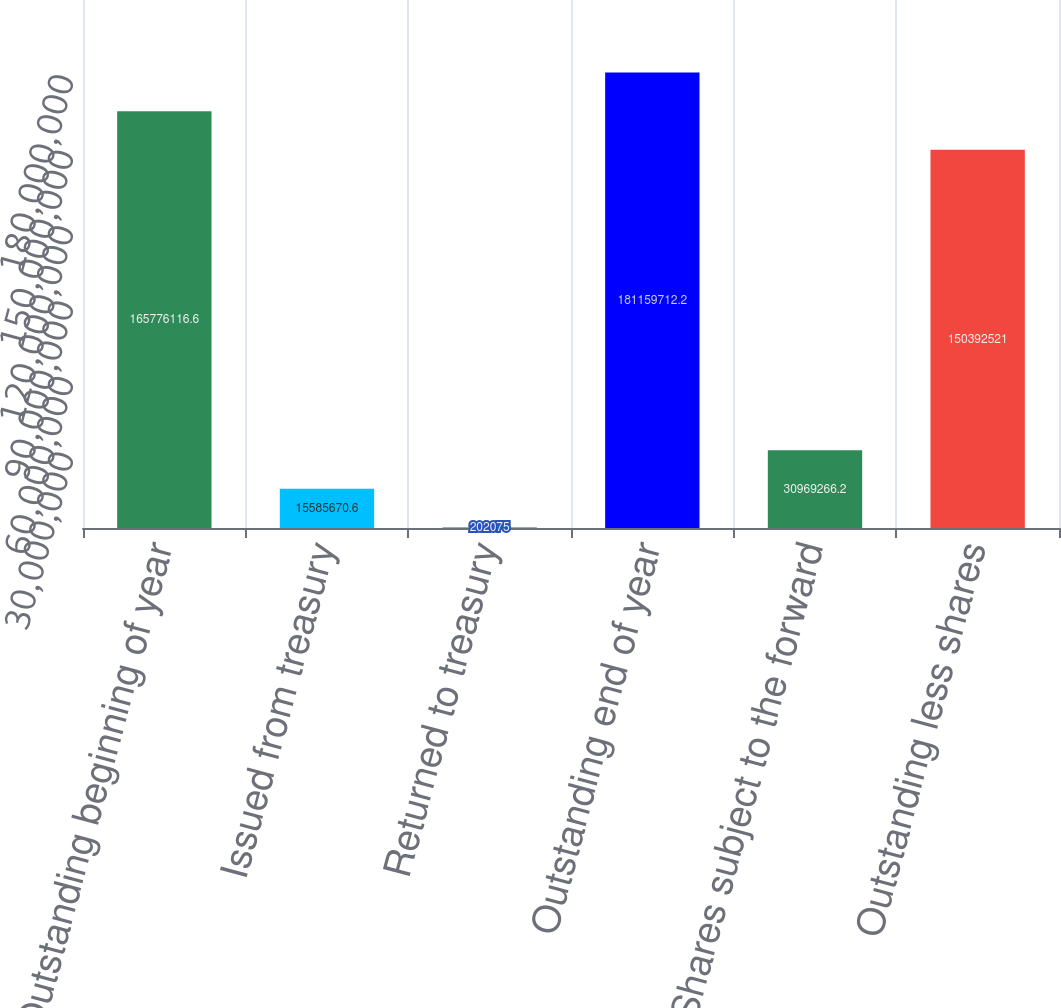Convert chart to OTSL. <chart><loc_0><loc_0><loc_500><loc_500><bar_chart><fcel>Outstanding beginning of year<fcel>Issued from treasury<fcel>Returned to treasury<fcel>Outstanding end of year<fcel>Shares subject to the forward<fcel>Outstanding less shares<nl><fcel>1.65776e+08<fcel>1.55857e+07<fcel>202075<fcel>1.8116e+08<fcel>3.09693e+07<fcel>1.50393e+08<nl></chart> 